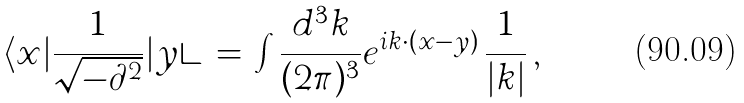Convert formula to latex. <formula><loc_0><loc_0><loc_500><loc_500>\langle x | \frac { 1 } { \sqrt { - \partial ^ { 2 } } } | y \rangle \, = \, \int \frac { d ^ { 3 } k } { ( 2 \pi ) ^ { 3 } } e ^ { i k \cdot ( x - y ) } \, \frac { 1 } { | k | } \, ,</formula> 